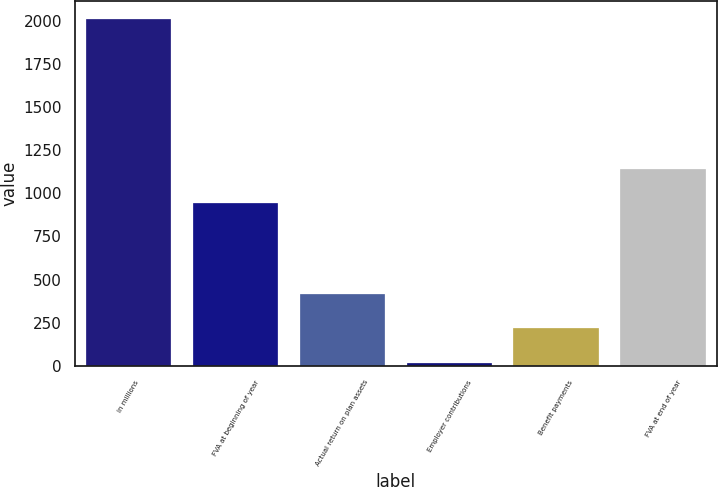Convert chart to OTSL. <chart><loc_0><loc_0><loc_500><loc_500><bar_chart><fcel>in millions<fcel>FVA at beginning of year<fcel>Actual return on plan assets<fcel>Employer contributions<fcel>Benefit payments<fcel>FVA at end of year<nl><fcel>2013<fcel>942<fcel>417<fcel>18<fcel>217.5<fcel>1141.5<nl></chart> 